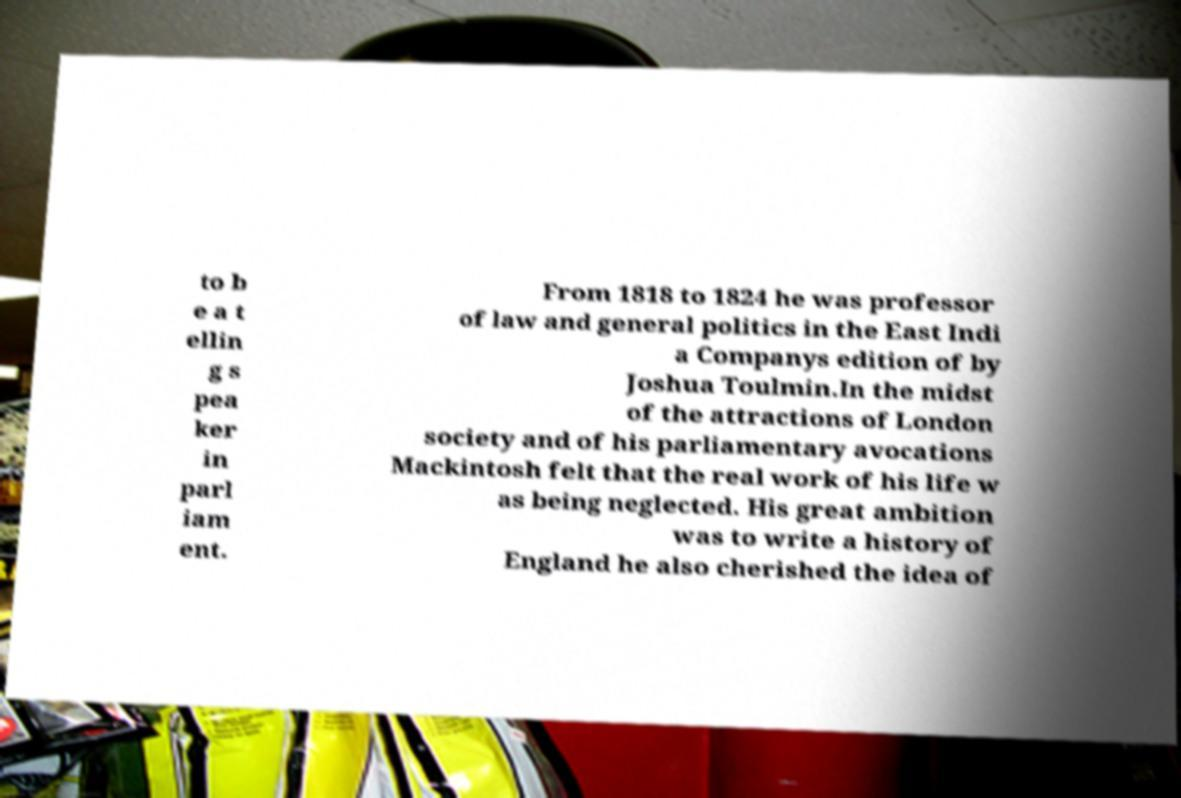Could you extract and type out the text from this image? to b e a t ellin g s pea ker in parl iam ent. From 1818 to 1824 he was professor of law and general politics in the East Indi a Companys edition of by Joshua Toulmin.In the midst of the attractions of London society and of his parliamentary avocations Mackintosh felt that the real work of his life w as being neglected. His great ambition was to write a history of England he also cherished the idea of 